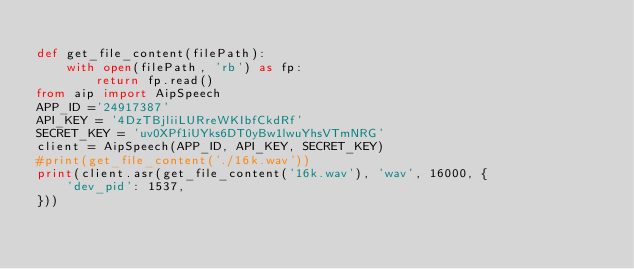Convert code to text. <code><loc_0><loc_0><loc_500><loc_500><_Python_>
def get_file_content(filePath):
    with open(filePath, 'rb') as fp:
        return fp.read()
from aip import AipSpeech
APP_ID ='24917387'
API_KEY = '4DzTBjliiLURreWKIbfCkdRf'
SECRET_KEY = 'uv0XPf1iUYks6DT0yBw1lwuYhsVTmNRG'
client = AipSpeech(APP_ID, API_KEY, SECRET_KEY)
#print(get_file_content('./16k.wav'))
print(client.asr(get_file_content('16k.wav'), 'wav', 16000, {
    'dev_pid': 1537,
}))
</code> 